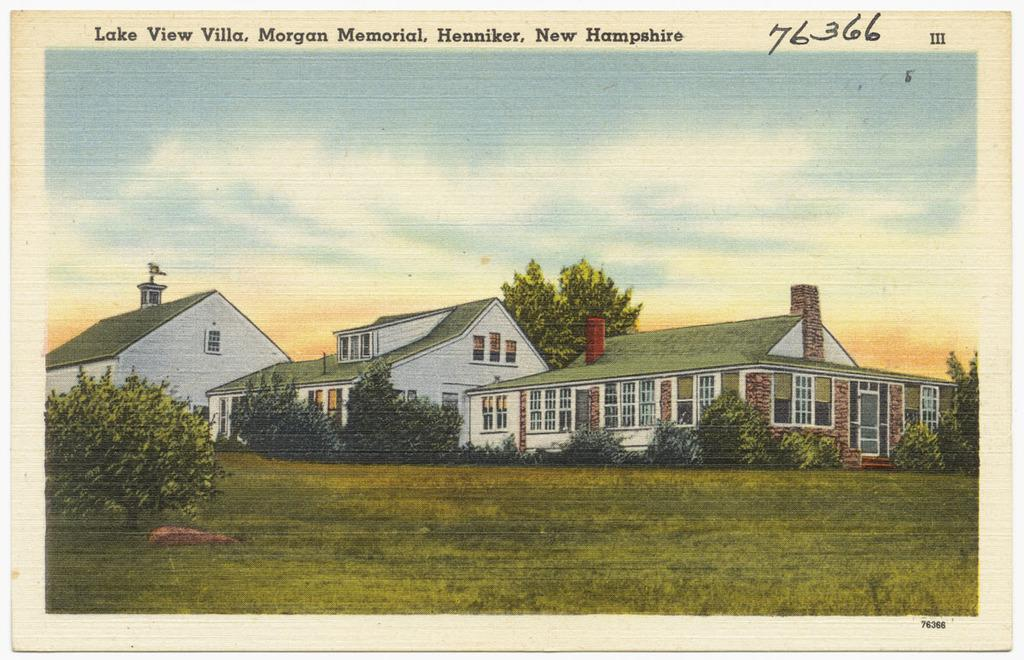<image>
Provide a brief description of the given image. Postcard with a short buliding from New Hampshire. 